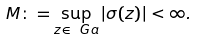<formula> <loc_0><loc_0><loc_500><loc_500>M \colon = \sup _ { z \in \ G a } | \sigma ( z ) | < \infty .</formula> 